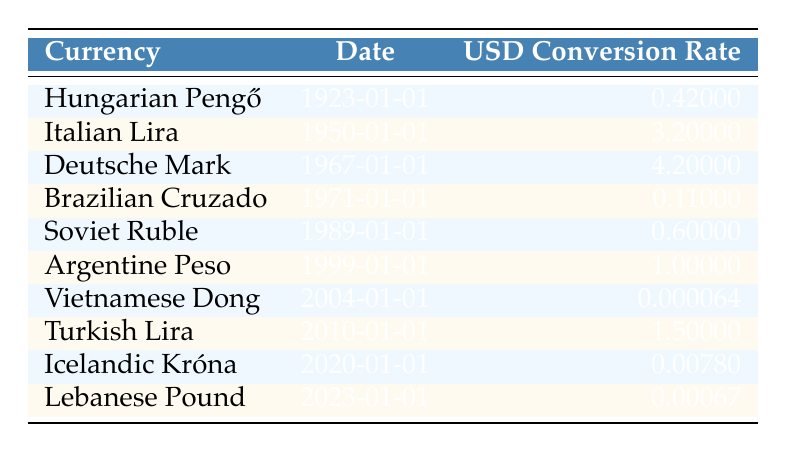What currency had the highest USD conversion rate from the table? By examining the "USD Conversion Rate" column, we see the values for each currency. The highest rate is for the "Italian Lira" at 3.20.
Answer: Italian Lira What was the USD conversion rate for the Hungarian Pengő in 1923? Looking at the row for "Hungarian Pengő" under the "Date" column, we find its corresponding "USD Conversion Rate" is 0.42.
Answer: 0.42 Which two currencies have a USD conversion rate less than 0.01? We need to check the "USD Conversion Rate" for all currencies. The "Vietnamese Dong" is 0.000064 and the "Lebanese Pound" is 0.00067, both of which are less than 0.01.
Answer: Vietnamese Dong and Lebanese Pound If we take the average of the USD conversion rates listed, what will it be approximately? First, we sum the rates: 0.42 + 3.20 + 4.20 + 0.11 + 0.60 + 1.00 + 0.000064 + 1.50 + 0.0078 + 0.00067 = 10.366834. There are 10 currencies, therefore: 10.366834 / 10 = 1.0366834, which we can round to approximately 1.04.
Answer: 1.04 Is the USD conversion rate for the Soviet Ruble higher than that of the Brazilian Cruzado? Comparing the two rates, the "Soviet Ruble" conversion rate is 0.60 while the "Brazilian Cruzado" conversion rate is 0.11; thus, 0.60 is indeed higher than 0.11.
Answer: Yes What was the USD conversion rate for Turkish Lira in 2010? The table specifies the conversion rate for "Turkish Lira" dated 2010 as 1.50 in the appropriate column.
Answer: 1.50 How many currencies have a conversion rate listed in the table that is greater than 1.00? From the table, we note that "Italian Lira" (3.20) and "Deutsche Mark" (4.20) are the only ones above 1.00. Thus, there are 2 currencies.
Answer: 2 What is the difference between the USD conversion rates of the Icelandic Króna and the Vietnamese Dong? The "Icelandic Króna" has a rate of 0.0078 while the "Vietnamese Dong" has a much lower rate of 0.000064. The difference is calculated as 0.0078 - 0.000064 = 0.007736.
Answer: 0.007736 